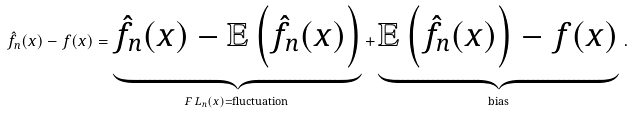<formula> <loc_0><loc_0><loc_500><loc_500>\hat { f } _ { n } ( x ) - f ( x ) = \underbrace { \hat { f } _ { n } ( x ) - \mathbb { E } \left ( \hat { f } _ { n } ( x ) \right ) } _ { F \, L _ { n } ( x ) = \text {fluctuation} } + \underbrace { \mathbb { E } \left ( \hat { f } _ { n } ( x ) \right ) - f ( x ) } _ { \text {bias} } \, .</formula> 